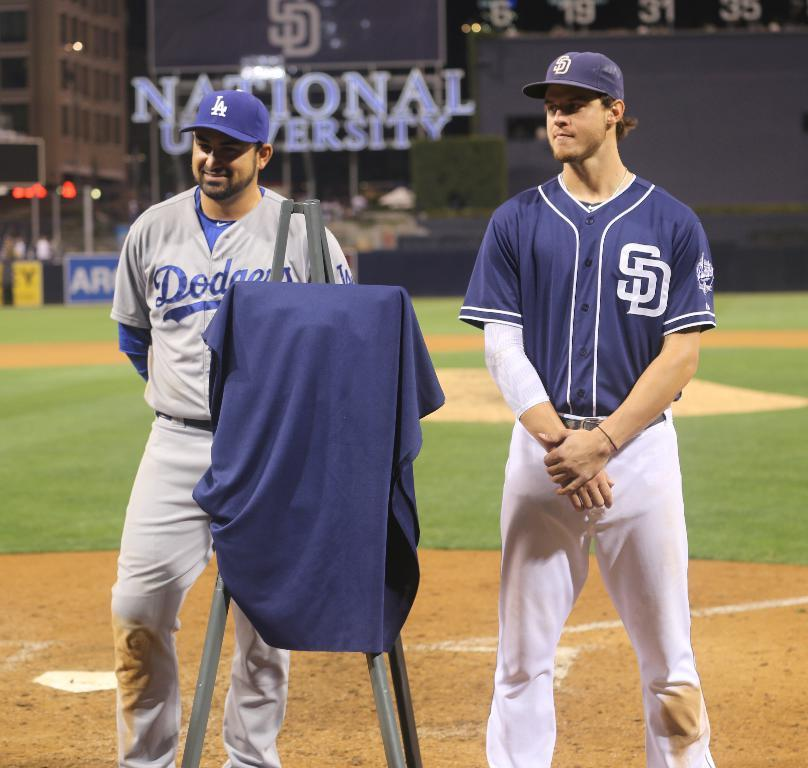Provide a one-sentence caption for the provided image. Two players for the Dodgers are standing on the field. 